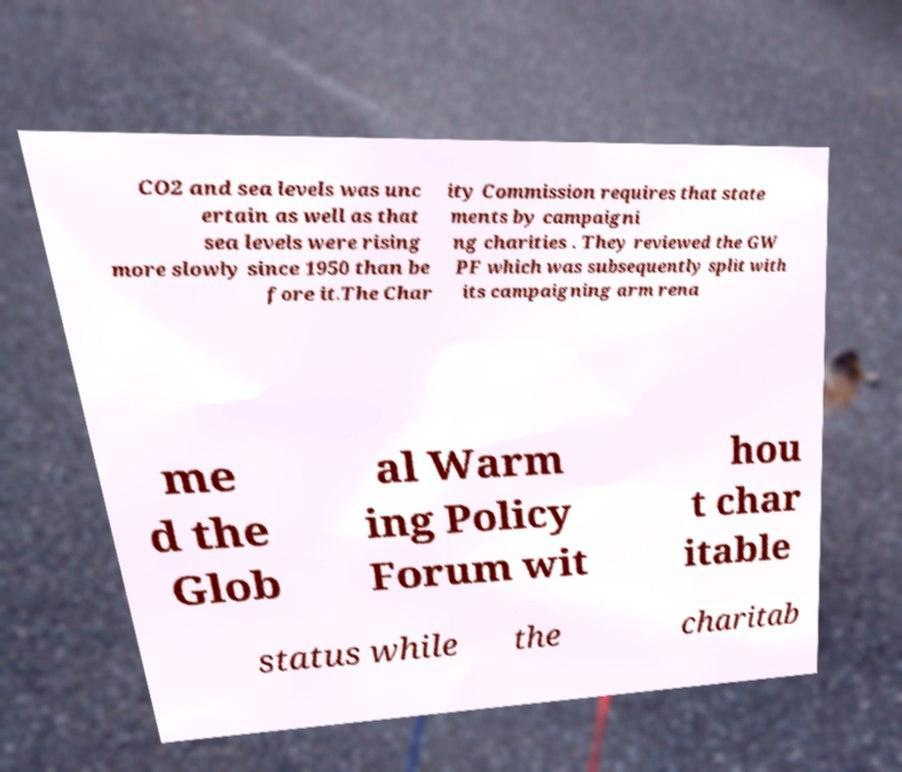Could you assist in decoding the text presented in this image and type it out clearly? CO2 and sea levels was unc ertain as well as that sea levels were rising more slowly since 1950 than be fore it.The Char ity Commission requires that state ments by campaigni ng charities . They reviewed the GW PF which was subsequently split with its campaigning arm rena me d the Glob al Warm ing Policy Forum wit hou t char itable status while the charitab 